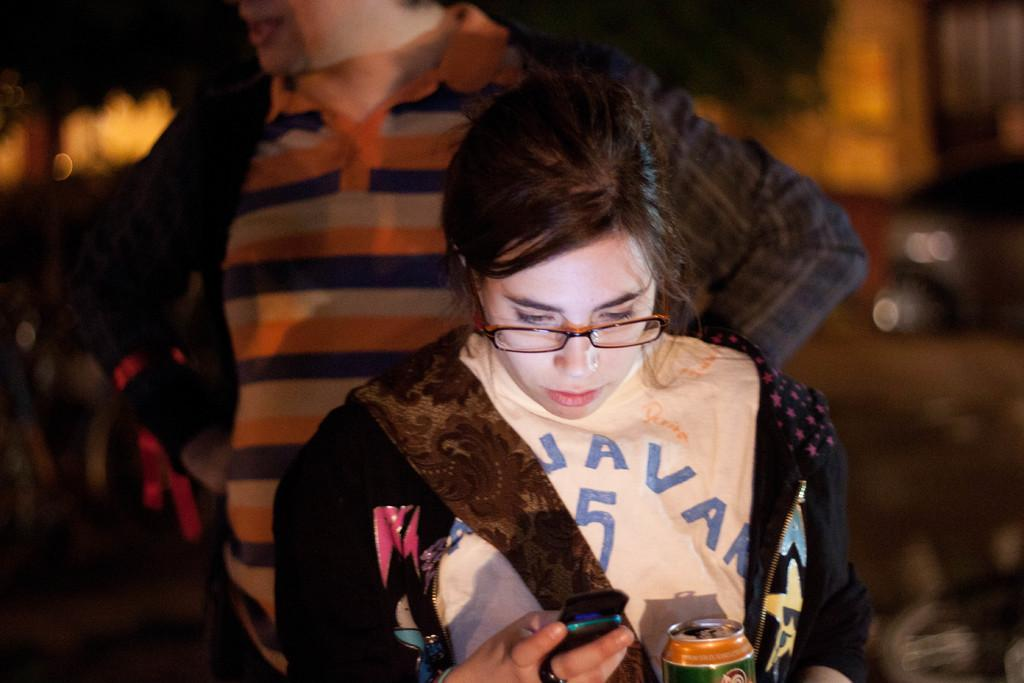What is the woman in the image holding? The woman is holding a mobile phone. What is the woman doing with the mobile phone? The woman is looking at the mobile phone. What is the woman wearing on her upper body? The woman is wearing a t-shirt. What accessory is the woman wearing on her face? The woman is wearing spectacles. Can you describe the man behind the woman? The man is wearing a coat and a t-shirt. What is the value of the birthday cake in the image? There is no birthday cake present in the image, so it is not possible to determine its value. 